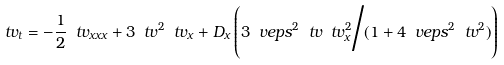<formula> <loc_0><loc_0><loc_500><loc_500>\ t v _ { t } = - \frac { 1 } { 2 } \ t v _ { x x x } + 3 \ t v ^ { 2 } \ t v _ { x } + D _ { x } \left ( { 3 \ v e p s ^ { 2 } \ t v \ t v _ { x } ^ { 2 } } \Big / { ( 1 + 4 \ v e p s ^ { 2 } \ t v ^ { 2 } ) } \right )</formula> 